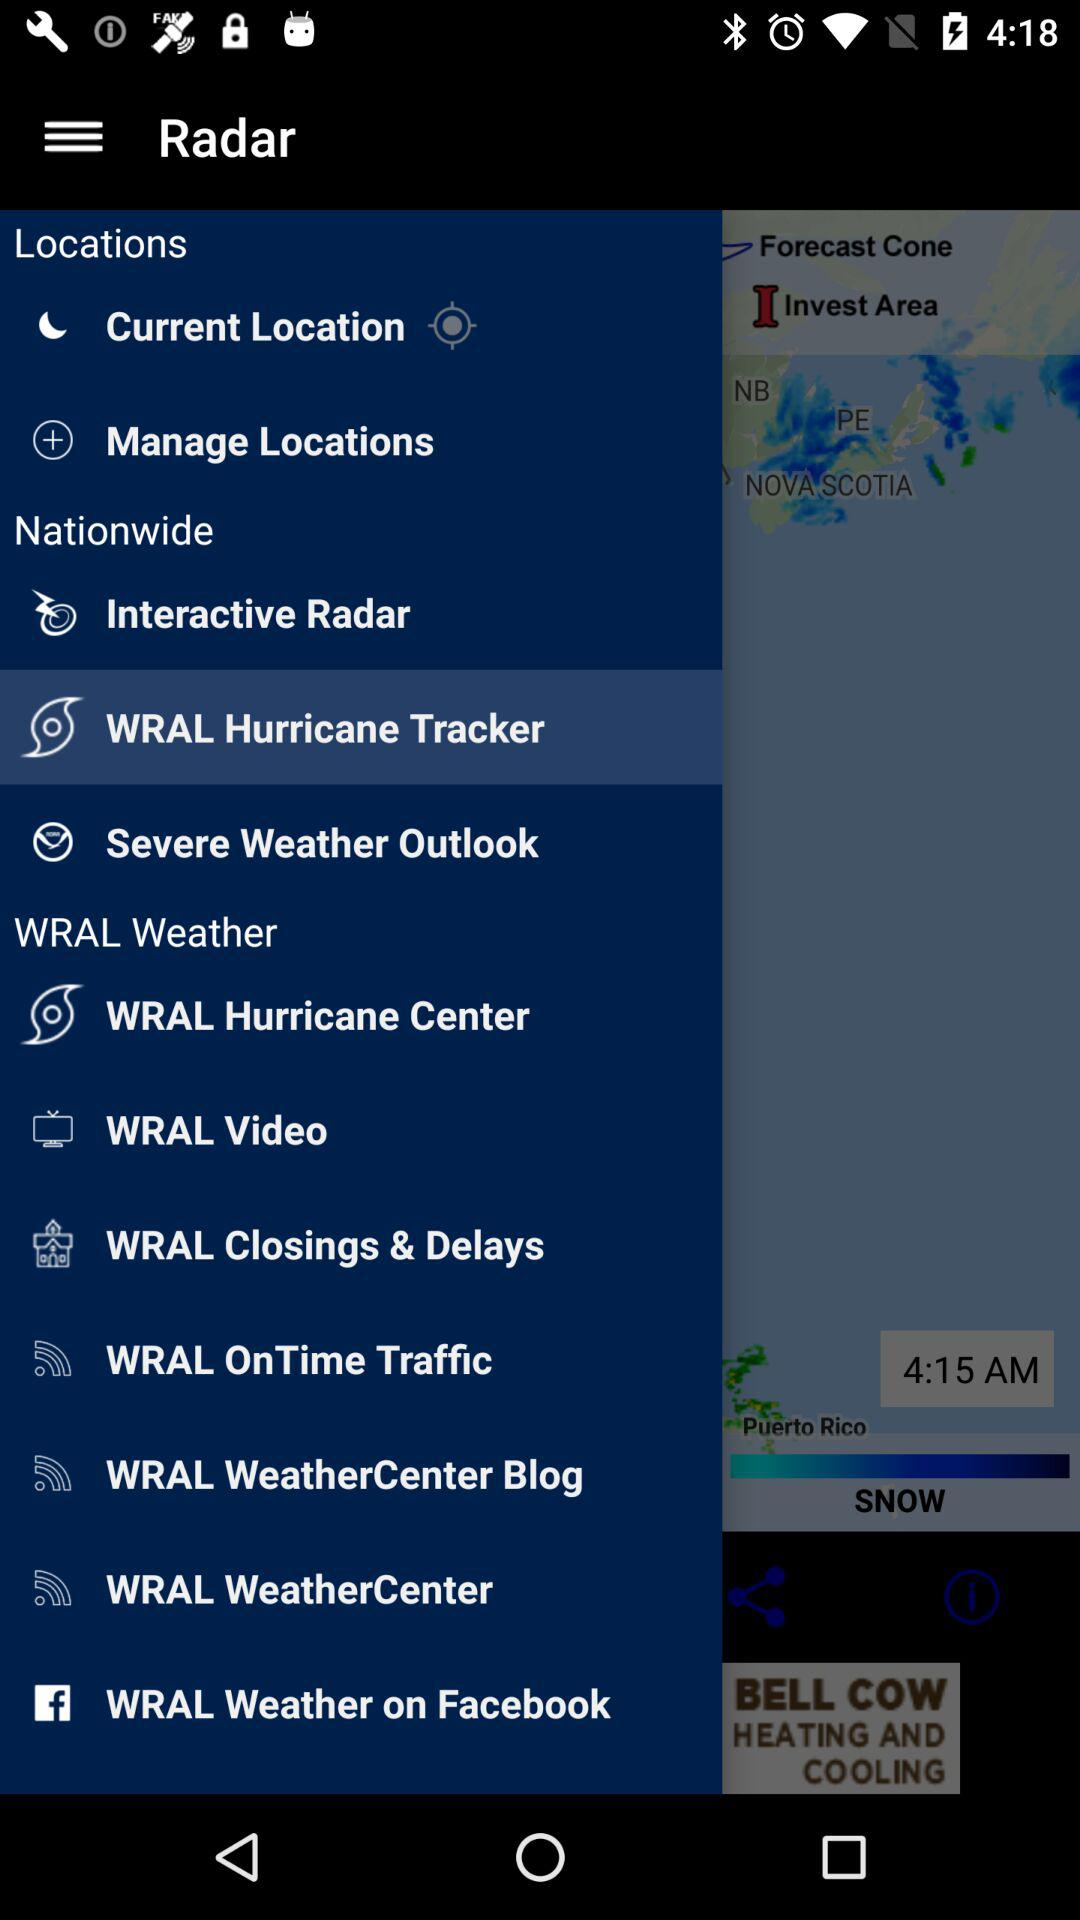How many notifications are there in "WRAL Video"?
When the provided information is insufficient, respond with <no answer>. <no answer> 